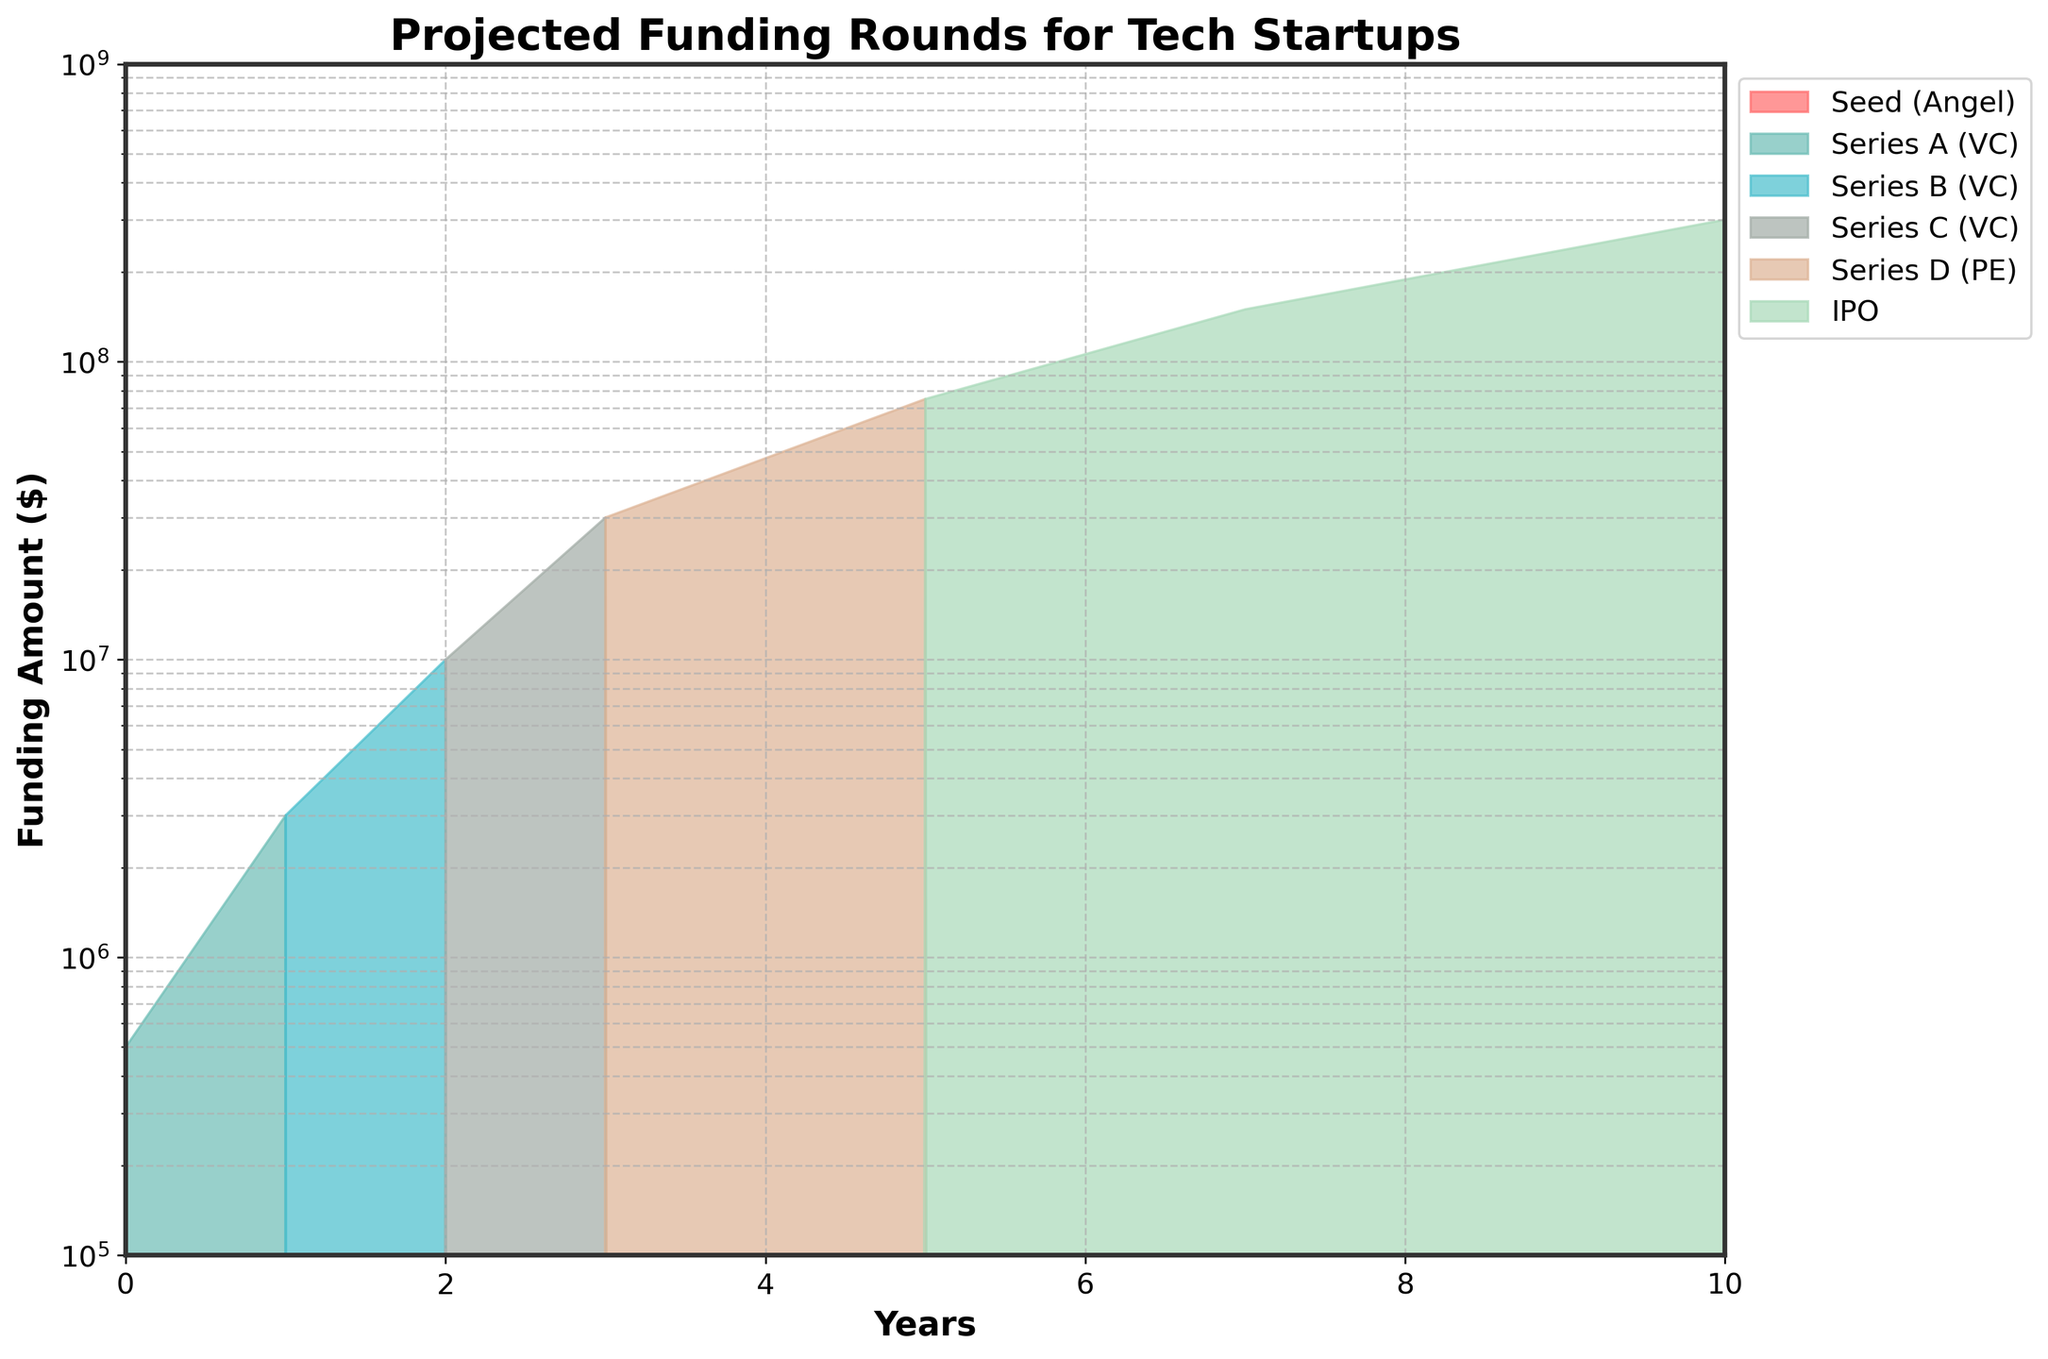What is the title of the chart? The title of the chart is displayed at the top center of the figure. It reads "Projected Funding Rounds for Tech Startups".
Answer: Projected Funding Rounds for Tech Startups What is the y-axis scale of the chart? Observing the y-axis labels, they are in logarithmic scale ranging from 100,000 to 1,000,000,000.
Answer: Logarithmic At which year does the IPO funding become significant? The largest colored area labeled as "IPO" appears from year 7 onwards in the chart.
Answer: Year 7 How many different funding rounds are shown in the chart? The chart depicts six different funding rounds, indicated by different colored areas in the legend on the right.
Answer: Six Which funding round has the highest single investment amount and in which year? By identifying the highest point of any colored area on the graph, we see "IPO" in year 10 with 300,000,000 as indicated by the chart's legend and position.
Answer: IPO in year 10 How do the funding amounts for Series A and Series D compare by Year 5? Series A (3,000,000) occurs in year 1 and Series D (75,000,000) occurs in year 5. Series D is greater than Series A by 72,000,000.
Answer: Series D is 72,000,000 more What is the cumulative funding after 10 years? Summing the maximum investment amounts for each year: 500,000 (year 0) + 3,000,000 (year 1) + 10,000,000 (year 2) + 30,000,000 (year 3) + 75,000,000 (year 5) + 150,000,000 (year 7) + 300,000,000 (year 10) gives a total funding amount of 568,500,000.
Answer: 568,500,000 Which two funding stages are closest in their funding amounts, according to the chart? The funding amounts for Seed (500,000) and Series A (3,000,000) appear closest to each other when comparing the height differences on the y-axis.
Answer: Seed and Series A 